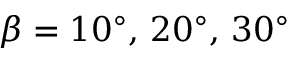<formula> <loc_0><loc_0><loc_500><loc_500>\beta = 1 0 ^ { \circ } , \, 2 0 ^ { \circ } , \, 3 0 ^ { \circ }</formula> 